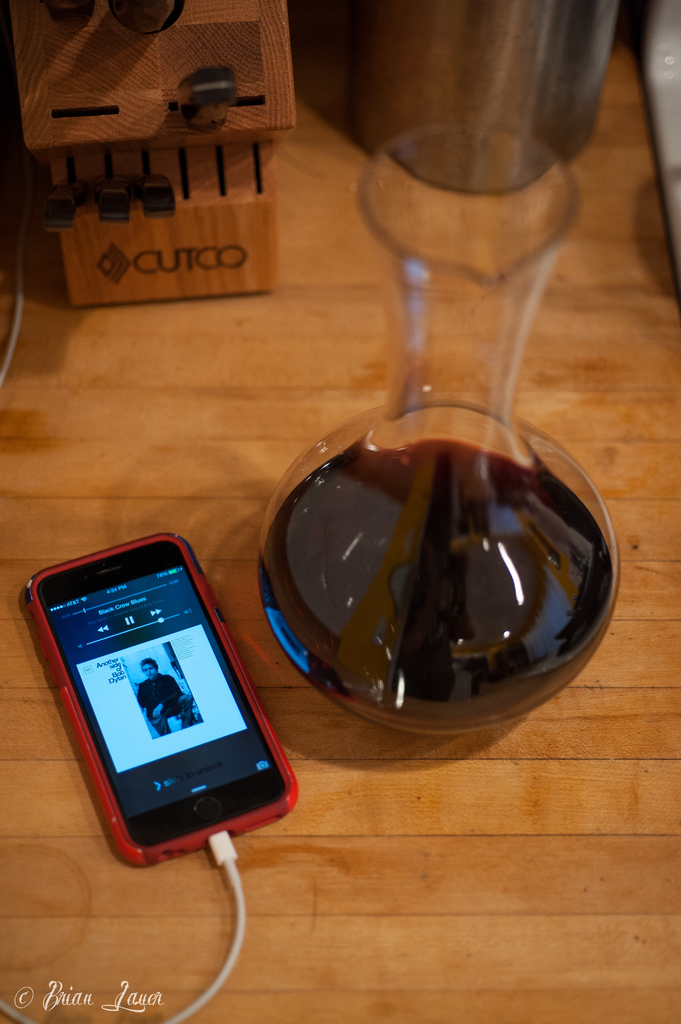Provide a one-sentence caption for the provided image. An iPhone displays the 'Black Crows Blues' song by Andrew Duhon, connected to a charger, next to a wine decanter filled with red wine, with a knife holder in the background. 